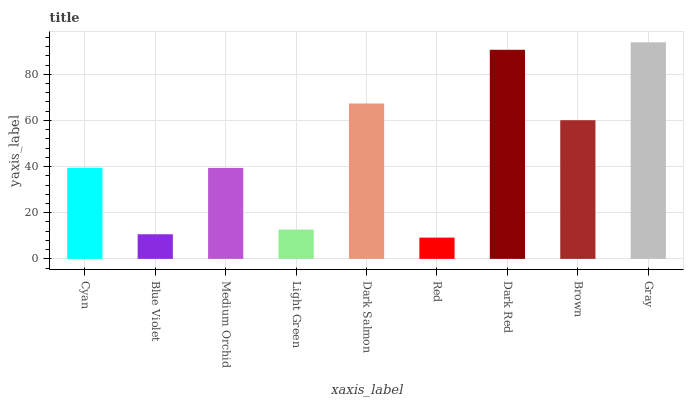Is Red the minimum?
Answer yes or no. Yes. Is Gray the maximum?
Answer yes or no. Yes. Is Blue Violet the minimum?
Answer yes or no. No. Is Blue Violet the maximum?
Answer yes or no. No. Is Cyan greater than Blue Violet?
Answer yes or no. Yes. Is Blue Violet less than Cyan?
Answer yes or no. Yes. Is Blue Violet greater than Cyan?
Answer yes or no. No. Is Cyan less than Blue Violet?
Answer yes or no. No. Is Cyan the high median?
Answer yes or no. Yes. Is Cyan the low median?
Answer yes or no. Yes. Is Gray the high median?
Answer yes or no. No. Is Medium Orchid the low median?
Answer yes or no. No. 